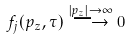<formula> <loc_0><loc_0><loc_500><loc_500>f _ { j } ( p _ { z } , \tau ) \stackrel { | p _ { z } | \rightarrow \infty } { \longrightarrow } 0</formula> 